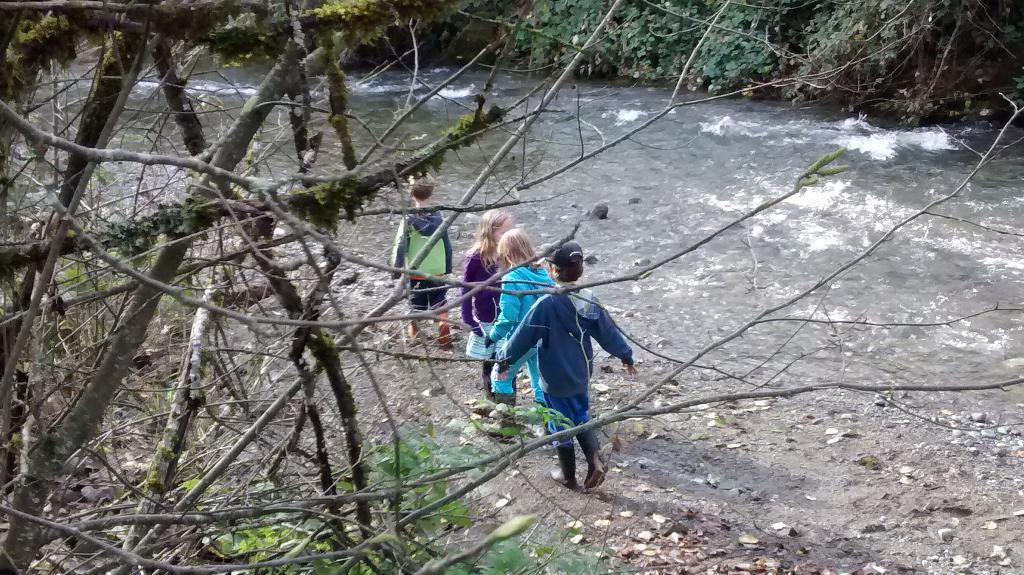What are the main subjects in the image? There are children walking in the image. What type of environment is depicted in the image? The image appears to depict a river. What can be seen in the background of the image? There are trees visible at the top of the image. What is the quality of the acoustics in the image? There is no information about the acoustics in the image, as it focuses on the visual aspects of the scene. --- Facts: 1. There is a car in the image. 2. The car is parked on the street. 3. There are buildings in the background of the image. 4. The car has a red color. Absurd Topics: parrot, sand, dance Conversation: What is the main subject in the image? There is a car in the image. Where is the car located? The car is parked on the street. What can be seen in the background of the image? There are buildings in the background of the image. What color is the car? The car has a red color. Reasoning: Let's think step by step in order to produce the conversation. We start by identifying the main subject in the image, which is the car. Then, we describe the location of the car, which is parked on the street. Next, we mention the background of the image, which includes buildings. Finally, we provide information about the car's color, which is red. Each question is designed to elicit a specific detail about the image that is known from the provided facts. Absurd Question/Answer: Can you see a parrot dancing on the car in the image? No, there is no parrot or dancing activity depicted in the image. 